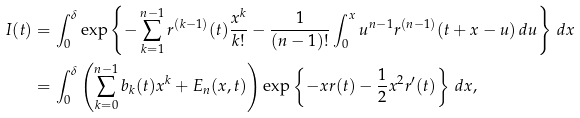<formula> <loc_0><loc_0><loc_500><loc_500>I ( t ) & = \int _ { 0 } ^ { \delta } \exp \left \{ - \sum _ { k = 1 } ^ { n - 1 } r ^ { ( k - 1 ) } ( t ) \frac { x ^ { k } } { k ! } - \frac { 1 } { ( n - 1 ) ! } \int _ { 0 } ^ { x } u ^ { n - 1 } r ^ { ( n - 1 ) } ( t + x - u ) \, d u \right \} \, d x \\ & = \int _ { 0 } ^ { \delta } \left ( \sum _ { k = 0 } ^ { n - 1 } b _ { k } ( t ) x ^ { k } + E _ { n } ( x , t ) \right ) \exp \left \{ - x r ( t ) - \frac { 1 } { 2 } x ^ { 2 } r ^ { \prime } ( t ) \right \} \, d x ,</formula> 